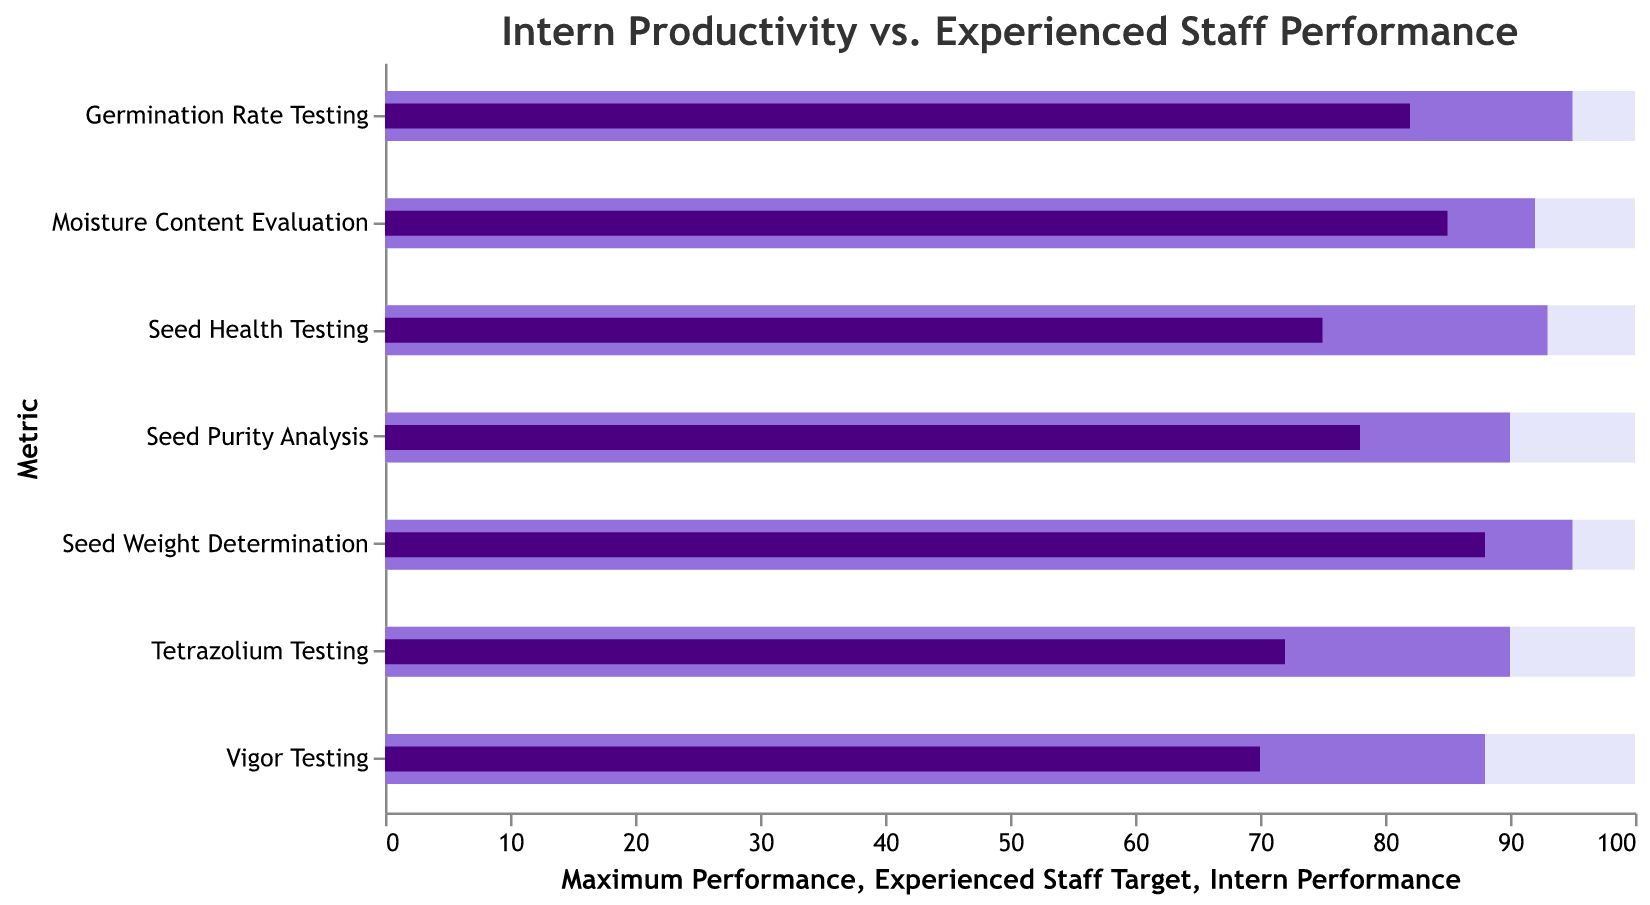What is the title of the chart? The title is displayed prominently at the top of the figure. It reads "Intern Productivity vs. Experienced Staff Performance".
Answer: Intern Productivity vs. Experienced Staff Performance What is the intern performance in Seed Weight Determination? To find the intern performance, locate "Seed Weight Determination" on the y-axis and see the value for "Intern Performance". It is represented by a dark bar. The value is 88.
Answer: 88 Which metric has the highest intern performance? Compare the values of intern performance for each metric. Seed Weight Determination has the highest value at 88.
Answer: Seed Weight Determination What is the difference between intern performance and experienced staff target for Vigor Testing? For Vigor Testing, intern performance is 70 and the experienced staff target is 88. The difference is 88 - 70 = 18.
Answer: 18 Among all metrics, which has the smallest difference between intern performance and experienced staff target? Calculate the differences for each metric: 
Germination Rate Testing: 95 - 82 = 13 
Seed Purity Analysis: 90 - 78 = 12 
Moisture Content Evaluation: 92 - 85 = 7 
Vigor Testing: 88 - 70 = 18 
Seed Health Testing: 93 - 75 = 18 
Seed Weight Determination: 95 - 88 = 7 
Tetrazolium Testing: 90 - 72 = 18 
The smallest differences are Moisture Content Evaluation and Seed Weight Determination, both at 7.
Answer: Moisture Content Evaluation and Seed Weight Determination Which metric has the largest gap between intern performance and maximum performance? Calculate the differences for each metric: 
Germination Rate Testing: 100 - 82 = 18 
Seed Purity Analysis: 100 - 78 = 22 
Moisture Content Evaluation: 100 - 85 = 15 
Vigor Testing: 100 - 70 = 30 
Seed Health Testing: 100 - 75 = 25 
Seed Weight Determination: 100 - 88 = 12 
Tetrazolium Testing: 100 - 72 = 28 
The largest gap is with Vigor Testing at 30.
Answer: Vigor Testing What metrics have intern performances over 80? Identify the metrics where the intern performance values (dark bars) exceed 80: 
Germination Rate Testing: 82 
Moisture Content Evaluation: 85 
Seed Weight Determination: 88
These are the metrics with intern performances over 80.
Answer: Germination Rate Testing, Moisture Content Evaluation, Seed Weight Determination What is the average intern performance across all metrics? Calculate the sum of intern performance values and then divide by the number of metrics: 
(82 + 78 + 85 + 70 + 75 + 88 + 72) = 550 
There are 7 metrics, so average = 550 / 7 = 78.57.
Answer: 78.57 